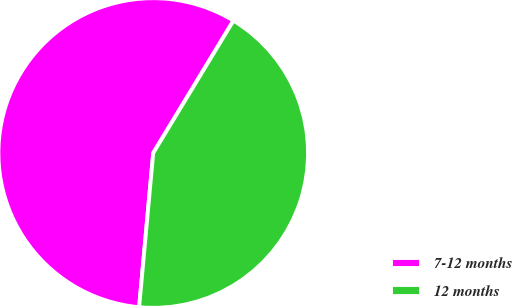<chart> <loc_0><loc_0><loc_500><loc_500><pie_chart><fcel>7-12 months<fcel>12 months<nl><fcel>57.22%<fcel>42.78%<nl></chart> 